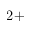<formula> <loc_0><loc_0><loc_500><loc_500>{ 2 + }</formula> 